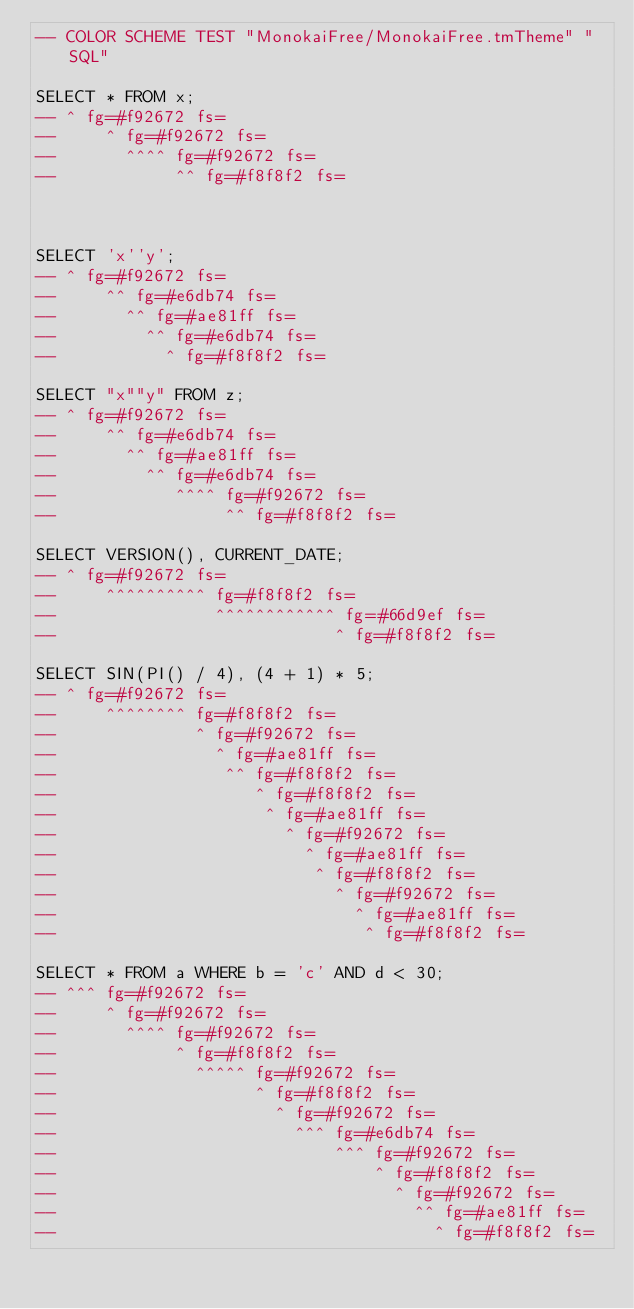Convert code to text. <code><loc_0><loc_0><loc_500><loc_500><_SQL_>-- COLOR SCHEME TEST "MonokaiFree/MonokaiFree.tmTheme" "SQL"

SELECT * FROM x;
-- ^ fg=#f92672 fs=
--     ^ fg=#f92672 fs=
--       ^^^^ fg=#f92672 fs=
--            ^^ fg=#f8f8f2 fs=



SELECT 'x''y';
-- ^ fg=#f92672 fs=
--     ^^ fg=#e6db74 fs=
--       ^^ fg=#ae81ff fs=
--         ^^ fg=#e6db74 fs=
--           ^ fg=#f8f8f2 fs=

SELECT "x""y" FROM z;
-- ^ fg=#f92672 fs=
--     ^^ fg=#e6db74 fs=
--       ^^ fg=#ae81ff fs=
--         ^^ fg=#e6db74 fs=
--            ^^^^ fg=#f92672 fs=
--                 ^^ fg=#f8f8f2 fs=

SELECT VERSION(), CURRENT_DATE;
-- ^ fg=#f92672 fs=
--     ^^^^^^^^^^ fg=#f8f8f2 fs=
--                ^^^^^^^^^^^^ fg=#66d9ef fs=
--                            ^ fg=#f8f8f2 fs=

SELECT SIN(PI() / 4), (4 + 1) * 5;
-- ^ fg=#f92672 fs=
--     ^^^^^^^^ fg=#f8f8f2 fs=
--              ^ fg=#f92672 fs=
--                ^ fg=#ae81ff fs=
--                 ^^ fg=#f8f8f2 fs=
--                    ^ fg=#f8f8f2 fs=
--                     ^ fg=#ae81ff fs=
--                       ^ fg=#f92672 fs=
--                         ^ fg=#ae81ff fs=
--                          ^ fg=#f8f8f2 fs=
--                            ^ fg=#f92672 fs=
--                              ^ fg=#ae81ff fs=
--                               ^ fg=#f8f8f2 fs=

SELECT * FROM a WHERE b = 'c' AND d < 30;
-- ^^^ fg=#f92672 fs=
--     ^ fg=#f92672 fs=
--       ^^^^ fg=#f92672 fs=
--            ^ fg=#f8f8f2 fs=
--              ^^^^^ fg=#f92672 fs=
--                    ^ fg=#f8f8f2 fs=
--                      ^ fg=#f92672 fs=
--                        ^^^ fg=#e6db74 fs=
--                            ^^^ fg=#f92672 fs=
--                                ^ fg=#f8f8f2 fs=
--                                  ^ fg=#f92672 fs=
--                                    ^^ fg=#ae81ff fs=
--                                      ^ fg=#f8f8f2 fs=
</code> 